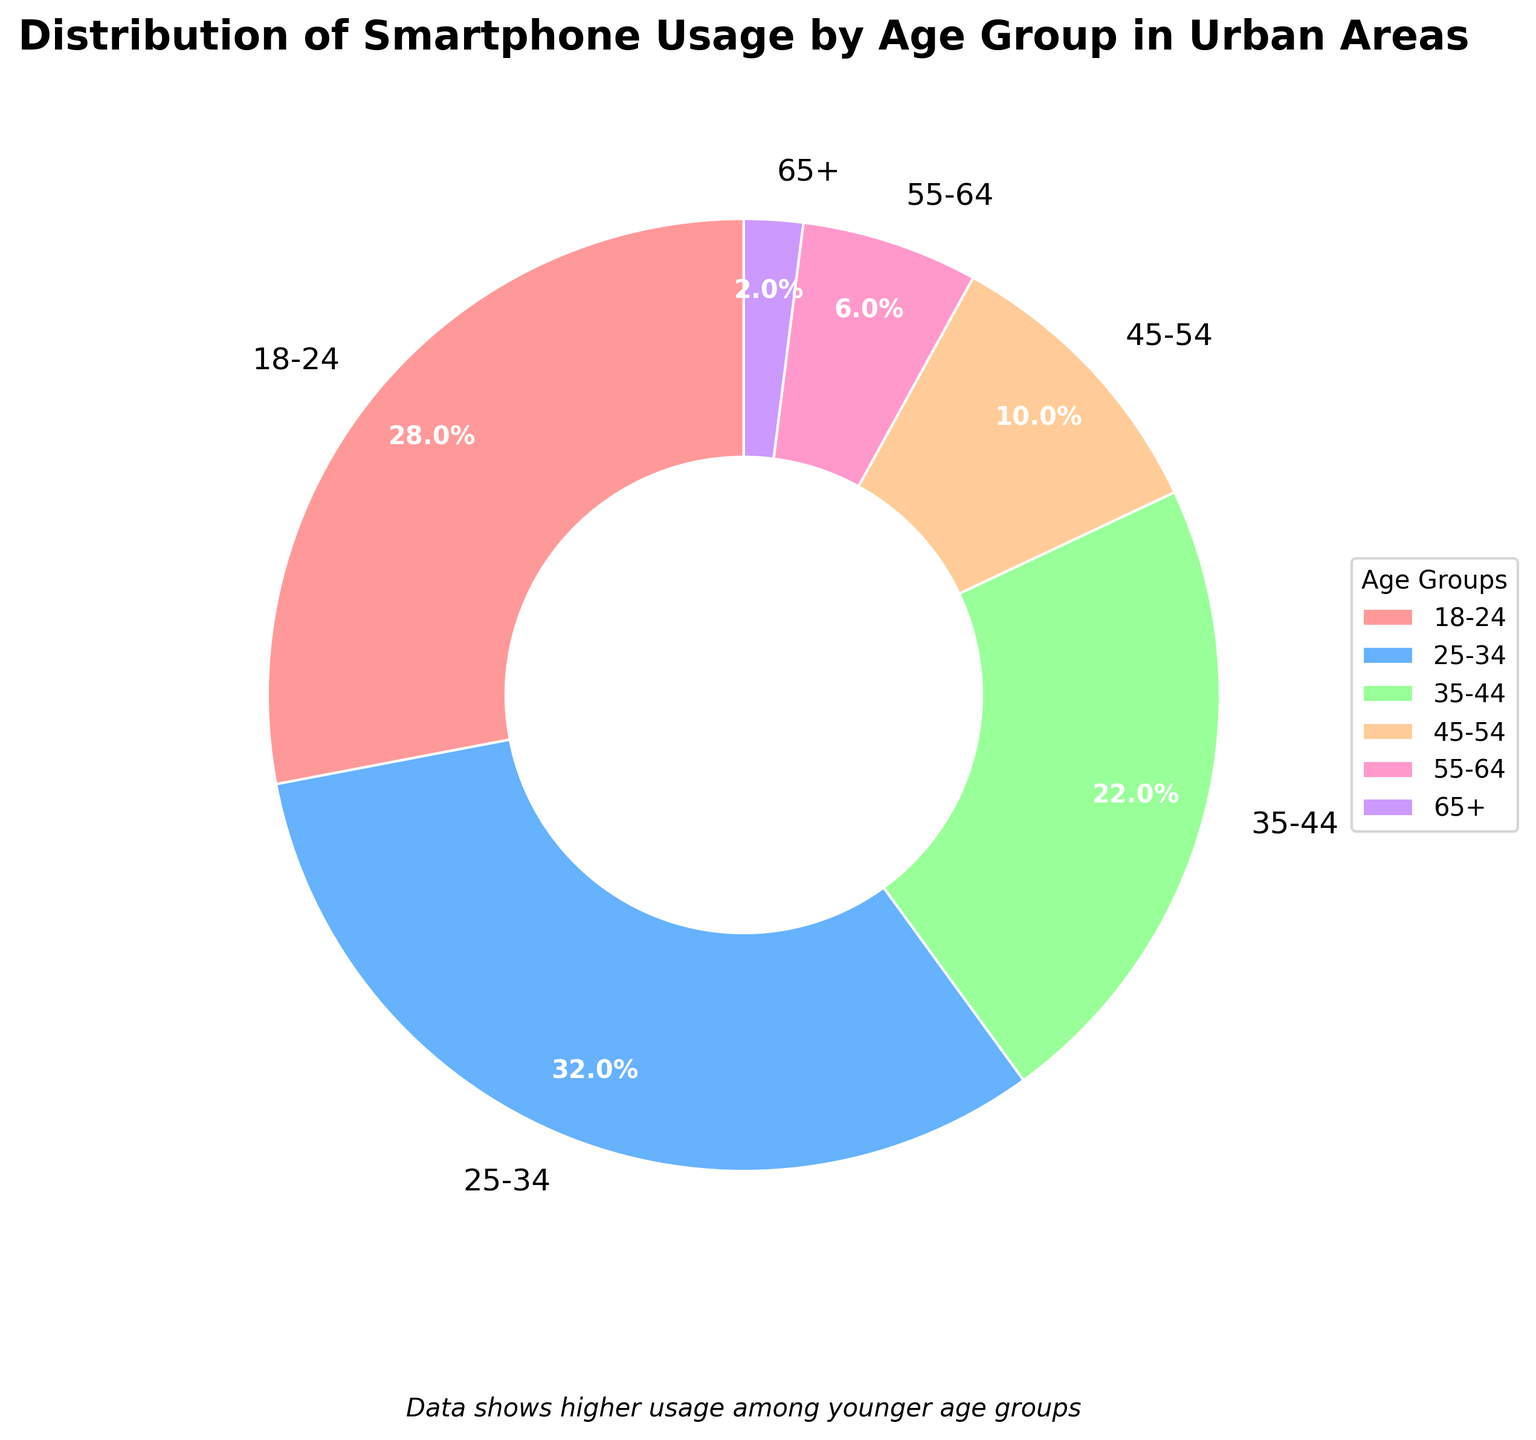What percentage of smartphone users in urban areas are aged 25-44? To find the combined percentage of the 25-34 and 35-44 age groups, add their individual percentages: 32% + 22%. So, 32 + 22 = 54%.
Answer: 54% Which age group has the highest percentage of smartphone usage in urban areas? Looking at the data, the age group 25-34 has the highest percentage at 32%.
Answer: 25-34 How much more is the smartphone usage percentage of the 18-24 age group compared to the 55-64 age group? Subtract the percentage of the 55-64 age group from the percentage of the 18-24 age group: 28% - 6% = 22%.
Answer: 22% What is the total percentage of smartphone users who are aged 45 and above? Add the percentages of the 45-54, 55-64, and 65+ age groups: 10% + 6% + 2%. Thus, 10 + 6 + 2 = 18%.
Answer: 18% Is the percentage of smartphone users aged 25-34 greater than the percentage of those aged 35-44? Yes, the 25-34 age group is 32%, which is higher than the 22% of the 35-44 age group.
Answer: Yes Which two age groups have a combined smartphone usage percentage close to 50%? The 18-24 age group at 28% combined with the 35-44 age group at 22% sums to 50%.
Answer: 18-24 and 35-44 What visual features help indicate that the age group 25-34 has the highest percentage of smartphone usage? The largest wedge in the pie chart represents the 25-34 age group. It occupies a significant portion of the chart, visually broader than other wedges.
Answer: Largest wedge How does the smartphone usage percentage of the 65+ age group compare to that of the 45-54 age group? The 65+ age group has a much lower percentage at 2%, compared to the 45-54 age group at 10%.
Answer: Lower What color represents the 18-24 age group in the pie chart, and why might this be helpful? The 18-24 age group is represented by a distinct color, likely to help differentiate it from other age groups and to visually analyze its proportion.
Answer: Red (assuming first color in the list) 